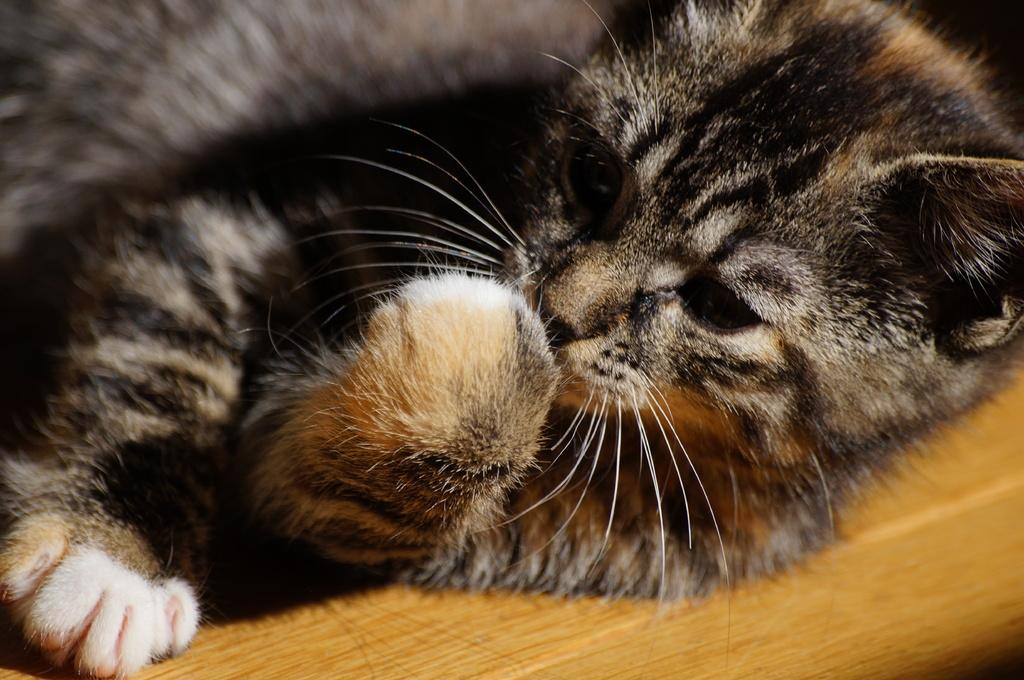What type of animal is in the image? There is a cat in the image. What is the cat sitting on? The cat is on a wooden surface. How many doors can be seen in the image? There are no doors visible in the image; it only features a cat on a wooden surface. 